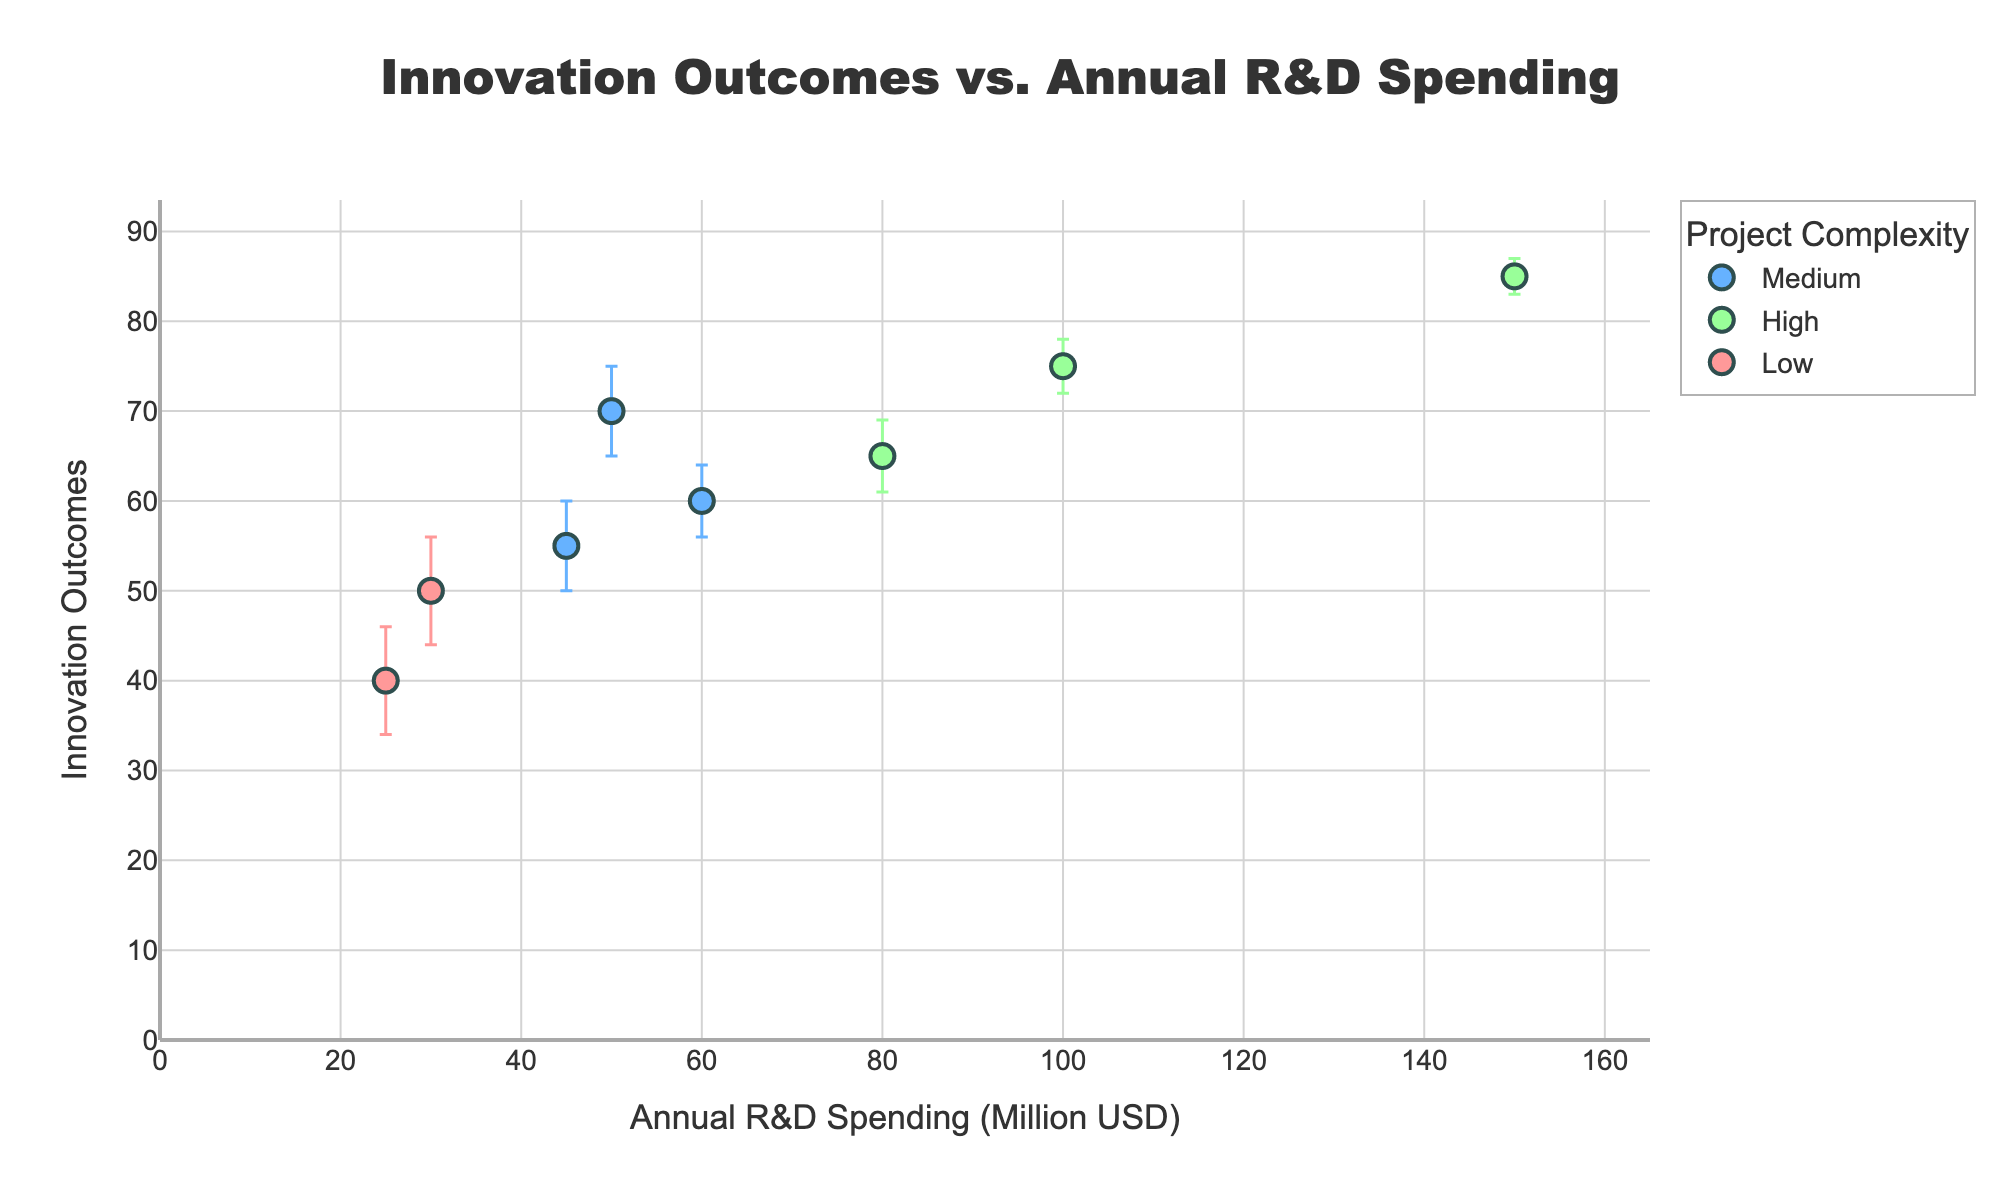What is the title of the figure? The title of the figure is displayed prominently at the top of the plot.
Answer: Innovation Outcomes vs. Annual R&D Spending How many data points represent projects with high complexity? We need to identify the markers corresponding to high complexity in the legend and count them in the plot.
Answer: 3 Which project has the highest innovation outcome? By looking at the highest y-axis value and identifying the corresponding project name.
Answer: Project Eta Which project spent the most on annual R&D? Find the data point farthest on the x-axis and note the project name.
Answer: Project Eta What are the error bars for Project Delta? Locate Project Delta on the plot and observe the size of the error bars on the y-axis.
Answer: ±3 What’s the average annual R&D spending for medium complexity projects? Sum the annual R&D spending of the medium complexity projects (Project Alpha, Project Epsilon, Project Zeta) and divide by the number of these projects: (50 + 45 + 60) / 3 = 51.67.
Answer: $51.67M Which project has the smallest error bar? Identify the data point with the least error range on the y-axis.
Answer: Project Eta How does the innovation outcome of Project Gamma compare to Project Alpha? Locate both projects on the y-axis and compare their y-values.
Answer: Project Gamma has a lower innovation outcome than Project Alpha What’s the difference in annual R&D spending between Project Beta and Project Theta? Subtract the lower x-value (Project Theta) from the higher x-value (Project Beta): 80 - 25 = 55.
Answer: $55M Among projects with medium complexity, which has the lowest innovation outcome? Compare the y-values of all medium complexity projects and identify the lowest one.
Answer: Project Zeta 